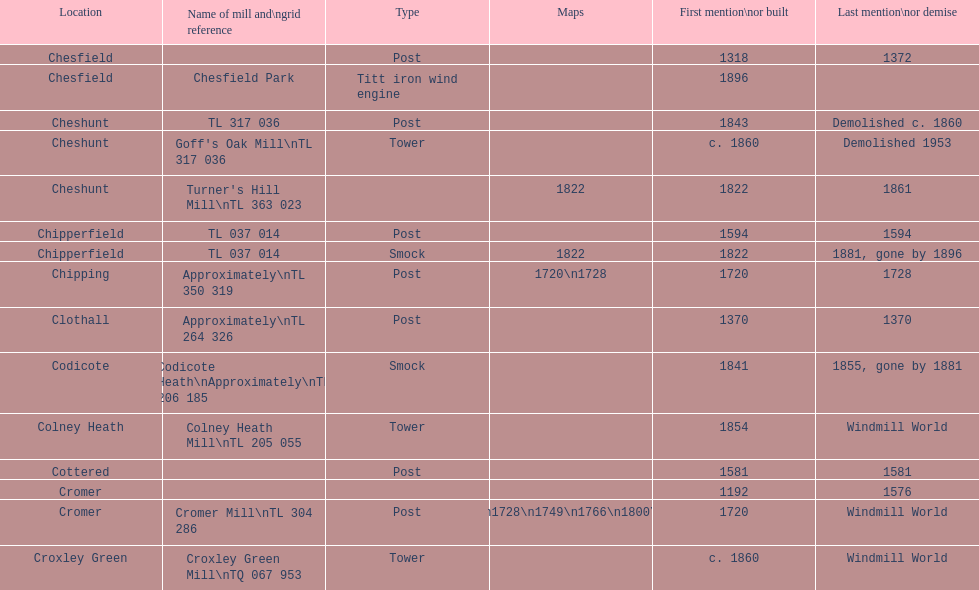In the 1800s, what was the count of mills that were initially built or brought up? 8. 